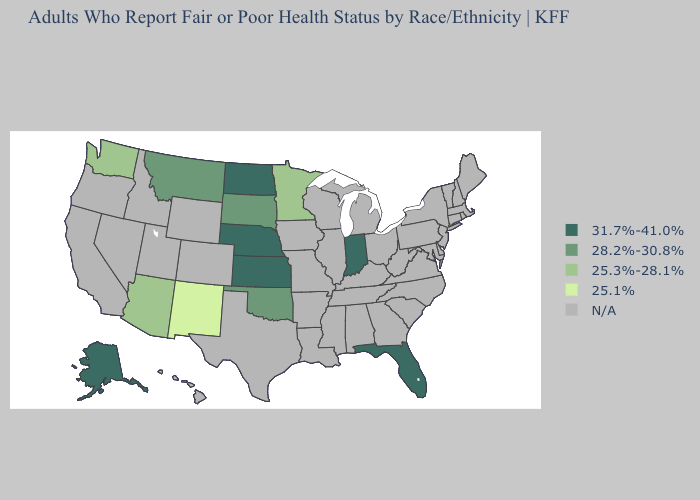Does Oklahoma have the highest value in the South?
Give a very brief answer. No. Which states have the lowest value in the USA?
Be succinct. New Mexico. Does the first symbol in the legend represent the smallest category?
Keep it brief. No. Does Montana have the lowest value in the USA?
Give a very brief answer. No. Does Florida have the lowest value in the South?
Answer briefly. No. Does New Mexico have the lowest value in the USA?
Quick response, please. Yes. Is the legend a continuous bar?
Write a very short answer. No. What is the value of Rhode Island?
Concise answer only. N/A. Which states have the lowest value in the USA?
Concise answer only. New Mexico. What is the value of Mississippi?
Concise answer only. N/A. Name the states that have a value in the range N/A?
Answer briefly. Alabama, Arkansas, California, Colorado, Connecticut, Delaware, Georgia, Hawaii, Idaho, Illinois, Iowa, Kentucky, Louisiana, Maine, Maryland, Massachusetts, Michigan, Mississippi, Missouri, Nevada, New Hampshire, New Jersey, New York, North Carolina, Ohio, Oregon, Pennsylvania, Rhode Island, South Carolina, Tennessee, Texas, Utah, Vermont, Virginia, West Virginia, Wisconsin, Wyoming. 